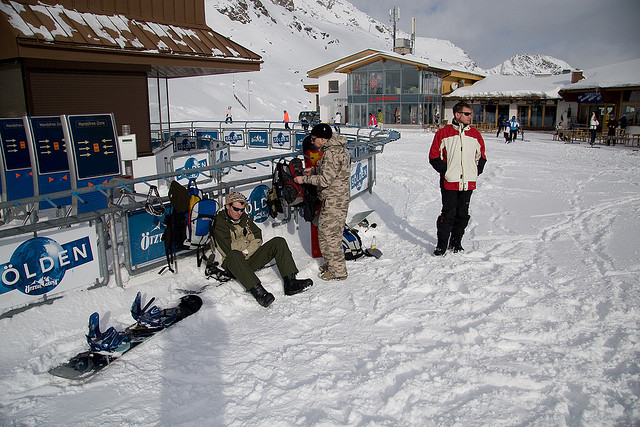Please transcribe the text in this image. OLDEN OLD GOLDEN 